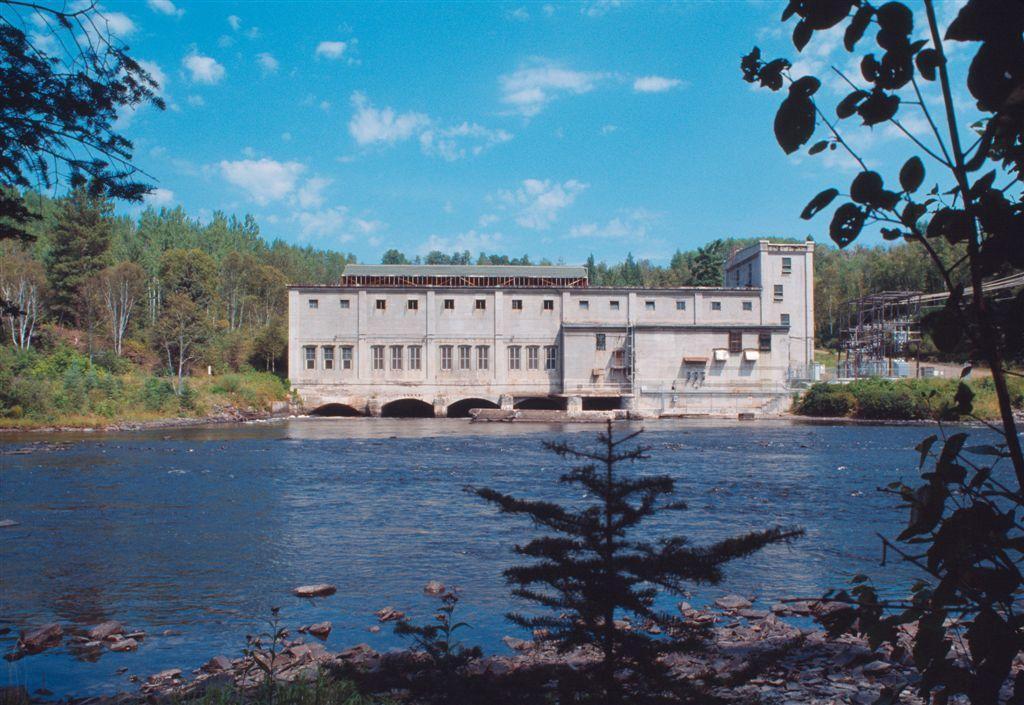Please provide a concise description of this image. In the center of the image there is a building. At the bottom there is water and we can see trees. In the background there is sky. 